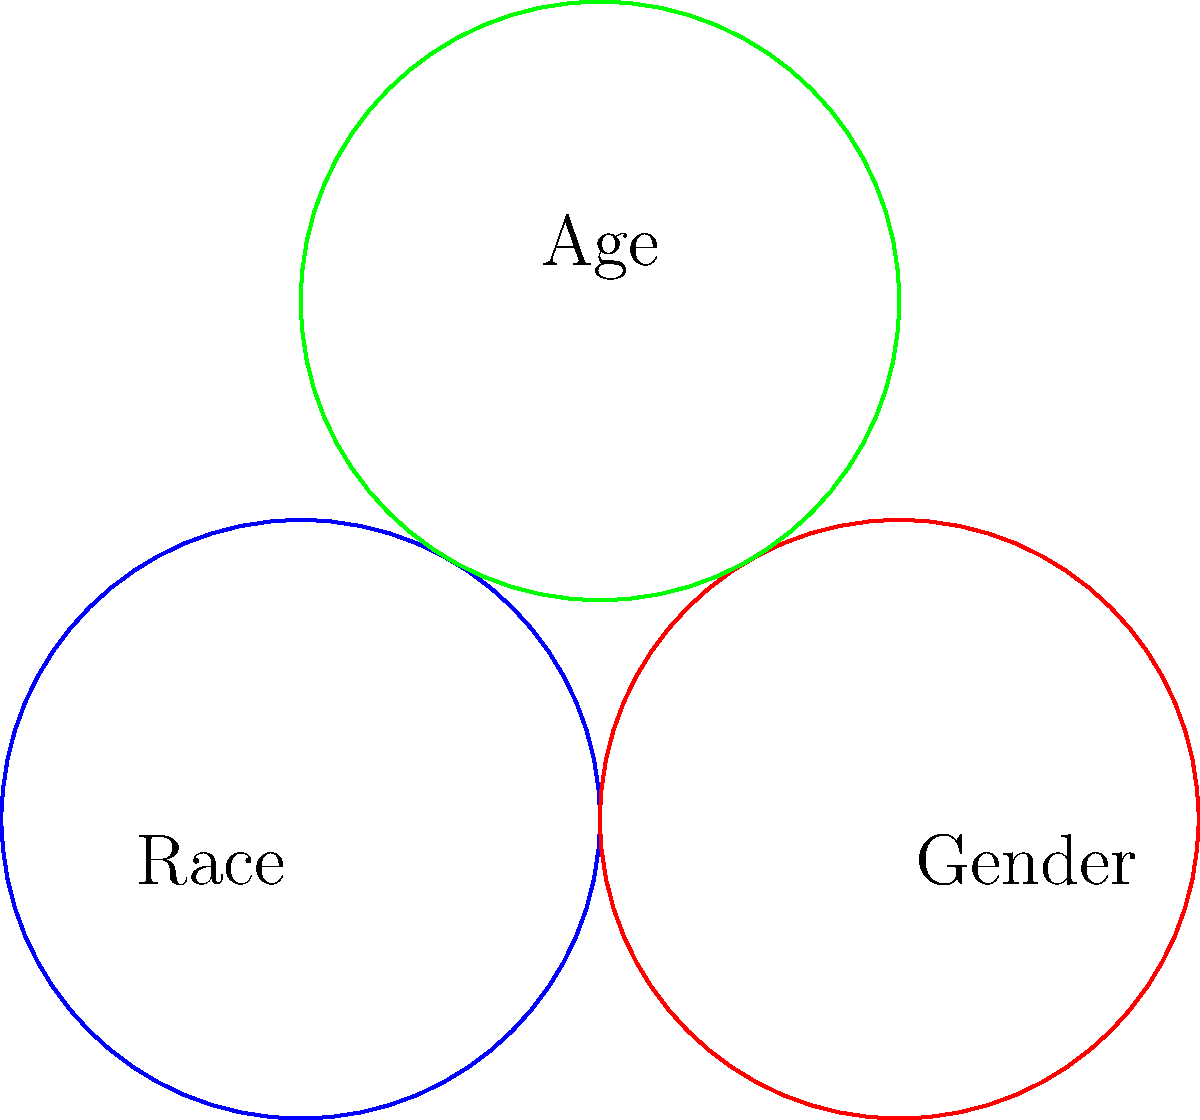In a study on workplace discrimination, three main factors are represented by overlapping circles: Race, Gender, and Age, each with a radius of 1 unit. The centers of these circles form an equilateral triangle with side length 2 units. Calculate the total area where at least two factors intersect, representing the concept of intersectionality in workplace discrimination. Round your answer to two decimal places. To solve this problem, we'll follow these steps:

1) First, we need to calculate the area of intersection between two circles. The formula for this is:

   $$A = 2r^2 \arccos(\frac{d}{2r}) - d\sqrt{r^2 - \frac{d^2}{4}}$$

   where $r$ is the radius and $d$ is the distance between centers.

2) In this case, $r = 1$ and $d = 2$. Substituting these values:

   $$A = 2(1)^2 \arccos(\frac{2}{2(1)}) - 2\sqrt{1^2 - \frac{2^2}{4}} = 2\arccos(1) - 2\sqrt{1 - 1} = 0$$

3) This means there's no intersection between any two circles alone.

4) Now, we need to calculate the area where all three circles intersect. This can be done using the formula for the area of a circular triangle:

   $$A_{\triangle} = 3(\frac{\pi}{3} - \frac{\sqrt{3}}{4})r^2$$

5) Substituting $r = 1$:

   $$A_{\triangle} = 3(\frac{\pi}{3} - \frac{\sqrt{3}}{4}) \approx 0.5865$$

6) The total area where at least two factors intersect is equal to this area.

7) Rounding to two decimal places: 0.59
Answer: 0.59 square units 